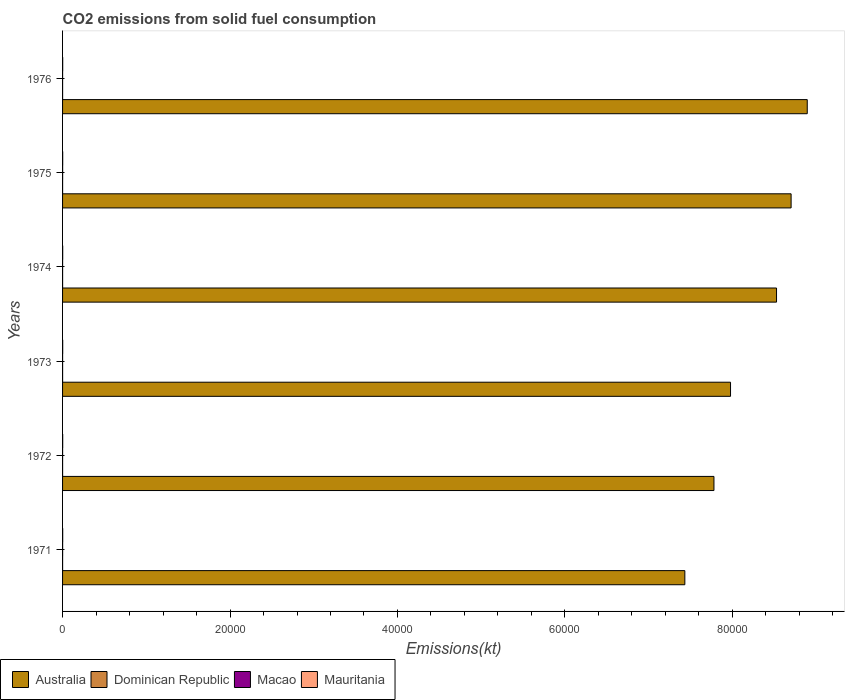How many different coloured bars are there?
Make the answer very short. 4. How many bars are there on the 4th tick from the top?
Offer a very short reply. 4. How many bars are there on the 6th tick from the bottom?
Make the answer very short. 4. What is the amount of CO2 emitted in Australia in 1973?
Provide a short and direct response. 7.98e+04. Across all years, what is the maximum amount of CO2 emitted in Macao?
Your response must be concise. 7.33. Across all years, what is the minimum amount of CO2 emitted in Australia?
Offer a terse response. 7.43e+04. What is the total amount of CO2 emitted in Dominican Republic in the graph?
Your answer should be very brief. 22. What is the difference between the amount of CO2 emitted in Macao in 1973 and the amount of CO2 emitted in Dominican Republic in 1974?
Your answer should be compact. 0. What is the average amount of CO2 emitted in Macao per year?
Your response must be concise. 4.89. In the year 1973, what is the difference between the amount of CO2 emitted in Dominican Republic and amount of CO2 emitted in Australia?
Offer a very short reply. -7.98e+04. In how many years, is the amount of CO2 emitted in Dominican Republic greater than 4000 kt?
Keep it short and to the point. 0. Is the amount of CO2 emitted in Australia in 1974 less than that in 1975?
Your answer should be compact. Yes. What is the difference between the highest and the lowest amount of CO2 emitted in Macao?
Make the answer very short. 3.67. In how many years, is the amount of CO2 emitted in Mauritania greater than the average amount of CO2 emitted in Mauritania taken over all years?
Ensure brevity in your answer.  0. Is the sum of the amount of CO2 emitted in Mauritania in 1972 and 1976 greater than the maximum amount of CO2 emitted in Dominican Republic across all years?
Keep it short and to the point. Yes. What does the 2nd bar from the top in 1971 represents?
Your answer should be compact. Macao. Are all the bars in the graph horizontal?
Your answer should be compact. Yes. How many years are there in the graph?
Offer a terse response. 6. What is the difference between two consecutive major ticks on the X-axis?
Provide a short and direct response. 2.00e+04. Are the values on the major ticks of X-axis written in scientific E-notation?
Offer a very short reply. No. Does the graph contain grids?
Your answer should be very brief. No. How many legend labels are there?
Provide a short and direct response. 4. How are the legend labels stacked?
Keep it short and to the point. Horizontal. What is the title of the graph?
Offer a very short reply. CO2 emissions from solid fuel consumption. What is the label or title of the X-axis?
Keep it short and to the point. Emissions(kt). What is the Emissions(kt) of Australia in 1971?
Your response must be concise. 7.43e+04. What is the Emissions(kt) in Dominican Republic in 1971?
Your answer should be compact. 3.67. What is the Emissions(kt) of Macao in 1971?
Provide a succinct answer. 7.33. What is the Emissions(kt) of Mauritania in 1971?
Ensure brevity in your answer.  14.67. What is the Emissions(kt) in Australia in 1972?
Make the answer very short. 7.78e+04. What is the Emissions(kt) in Dominican Republic in 1972?
Keep it short and to the point. 3.67. What is the Emissions(kt) of Macao in 1972?
Provide a short and direct response. 3.67. What is the Emissions(kt) of Mauritania in 1972?
Your answer should be compact. 14.67. What is the Emissions(kt) of Australia in 1973?
Make the answer very short. 7.98e+04. What is the Emissions(kt) in Dominican Republic in 1973?
Provide a short and direct response. 3.67. What is the Emissions(kt) in Macao in 1973?
Give a very brief answer. 3.67. What is the Emissions(kt) of Mauritania in 1973?
Your response must be concise. 14.67. What is the Emissions(kt) in Australia in 1974?
Your answer should be compact. 8.53e+04. What is the Emissions(kt) in Dominican Republic in 1974?
Provide a succinct answer. 3.67. What is the Emissions(kt) of Macao in 1974?
Ensure brevity in your answer.  3.67. What is the Emissions(kt) in Mauritania in 1974?
Provide a succinct answer. 14.67. What is the Emissions(kt) of Australia in 1975?
Your response must be concise. 8.70e+04. What is the Emissions(kt) of Dominican Republic in 1975?
Your answer should be very brief. 3.67. What is the Emissions(kt) of Macao in 1975?
Your answer should be compact. 7.33. What is the Emissions(kt) of Mauritania in 1975?
Give a very brief answer. 14.67. What is the Emissions(kt) of Australia in 1976?
Keep it short and to the point. 8.89e+04. What is the Emissions(kt) of Dominican Republic in 1976?
Keep it short and to the point. 3.67. What is the Emissions(kt) in Macao in 1976?
Your response must be concise. 3.67. What is the Emissions(kt) of Mauritania in 1976?
Provide a succinct answer. 14.67. Across all years, what is the maximum Emissions(kt) of Australia?
Your answer should be very brief. 8.89e+04. Across all years, what is the maximum Emissions(kt) of Dominican Republic?
Offer a very short reply. 3.67. Across all years, what is the maximum Emissions(kt) in Macao?
Your answer should be compact. 7.33. Across all years, what is the maximum Emissions(kt) of Mauritania?
Keep it short and to the point. 14.67. Across all years, what is the minimum Emissions(kt) in Australia?
Your answer should be very brief. 7.43e+04. Across all years, what is the minimum Emissions(kt) in Dominican Republic?
Your response must be concise. 3.67. Across all years, what is the minimum Emissions(kt) in Macao?
Offer a terse response. 3.67. Across all years, what is the minimum Emissions(kt) in Mauritania?
Your answer should be compact. 14.67. What is the total Emissions(kt) in Australia in the graph?
Give a very brief answer. 4.93e+05. What is the total Emissions(kt) in Dominican Republic in the graph?
Make the answer very short. 22. What is the total Emissions(kt) of Macao in the graph?
Your answer should be compact. 29.34. What is the total Emissions(kt) of Mauritania in the graph?
Give a very brief answer. 88.01. What is the difference between the Emissions(kt) in Australia in 1971 and that in 1972?
Offer a terse response. -3476.32. What is the difference between the Emissions(kt) in Dominican Republic in 1971 and that in 1972?
Make the answer very short. 0. What is the difference between the Emissions(kt) in Macao in 1971 and that in 1972?
Keep it short and to the point. 3.67. What is the difference between the Emissions(kt) of Mauritania in 1971 and that in 1972?
Provide a short and direct response. 0. What is the difference between the Emissions(kt) in Australia in 1971 and that in 1973?
Offer a terse response. -5456.5. What is the difference between the Emissions(kt) of Dominican Republic in 1971 and that in 1973?
Offer a very short reply. 0. What is the difference between the Emissions(kt) in Macao in 1971 and that in 1973?
Keep it short and to the point. 3.67. What is the difference between the Emissions(kt) in Mauritania in 1971 and that in 1973?
Keep it short and to the point. 0. What is the difference between the Emissions(kt) of Australia in 1971 and that in 1974?
Offer a very short reply. -1.09e+04. What is the difference between the Emissions(kt) of Dominican Republic in 1971 and that in 1974?
Provide a succinct answer. 0. What is the difference between the Emissions(kt) in Macao in 1971 and that in 1974?
Offer a very short reply. 3.67. What is the difference between the Emissions(kt) in Mauritania in 1971 and that in 1974?
Your answer should be compact. 0. What is the difference between the Emissions(kt) in Australia in 1971 and that in 1975?
Keep it short and to the point. -1.27e+04. What is the difference between the Emissions(kt) of Australia in 1971 and that in 1976?
Keep it short and to the point. -1.46e+04. What is the difference between the Emissions(kt) of Macao in 1971 and that in 1976?
Make the answer very short. 3.67. What is the difference between the Emissions(kt) in Mauritania in 1971 and that in 1976?
Your answer should be very brief. 0. What is the difference between the Emissions(kt) in Australia in 1972 and that in 1973?
Offer a terse response. -1980.18. What is the difference between the Emissions(kt) of Dominican Republic in 1972 and that in 1973?
Provide a short and direct response. 0. What is the difference between the Emissions(kt) of Macao in 1972 and that in 1973?
Your answer should be compact. 0. What is the difference between the Emissions(kt) of Mauritania in 1972 and that in 1973?
Ensure brevity in your answer.  0. What is the difference between the Emissions(kt) of Australia in 1972 and that in 1974?
Your response must be concise. -7473.35. What is the difference between the Emissions(kt) in Dominican Republic in 1972 and that in 1974?
Offer a very short reply. 0. What is the difference between the Emissions(kt) in Australia in 1972 and that in 1975?
Give a very brief answer. -9215.17. What is the difference between the Emissions(kt) of Macao in 1972 and that in 1975?
Provide a short and direct response. -3.67. What is the difference between the Emissions(kt) of Mauritania in 1972 and that in 1975?
Your response must be concise. 0. What is the difference between the Emissions(kt) of Australia in 1972 and that in 1976?
Your answer should be very brief. -1.11e+04. What is the difference between the Emissions(kt) of Dominican Republic in 1972 and that in 1976?
Your answer should be compact. 0. What is the difference between the Emissions(kt) of Macao in 1972 and that in 1976?
Your answer should be very brief. 0. What is the difference between the Emissions(kt) of Mauritania in 1972 and that in 1976?
Offer a terse response. 0. What is the difference between the Emissions(kt) in Australia in 1973 and that in 1974?
Your response must be concise. -5493.17. What is the difference between the Emissions(kt) in Dominican Republic in 1973 and that in 1974?
Give a very brief answer. 0. What is the difference between the Emissions(kt) of Macao in 1973 and that in 1974?
Provide a succinct answer. 0. What is the difference between the Emissions(kt) of Australia in 1973 and that in 1975?
Your response must be concise. -7234.99. What is the difference between the Emissions(kt) in Macao in 1973 and that in 1975?
Your response must be concise. -3.67. What is the difference between the Emissions(kt) of Australia in 1973 and that in 1976?
Your answer should be very brief. -9163.83. What is the difference between the Emissions(kt) of Dominican Republic in 1973 and that in 1976?
Make the answer very short. 0. What is the difference between the Emissions(kt) of Australia in 1974 and that in 1975?
Give a very brief answer. -1741.83. What is the difference between the Emissions(kt) of Dominican Republic in 1974 and that in 1975?
Offer a very short reply. 0. What is the difference between the Emissions(kt) of Macao in 1974 and that in 1975?
Ensure brevity in your answer.  -3.67. What is the difference between the Emissions(kt) in Mauritania in 1974 and that in 1975?
Provide a short and direct response. 0. What is the difference between the Emissions(kt) in Australia in 1974 and that in 1976?
Your answer should be very brief. -3670.67. What is the difference between the Emissions(kt) of Macao in 1974 and that in 1976?
Offer a terse response. 0. What is the difference between the Emissions(kt) of Mauritania in 1974 and that in 1976?
Keep it short and to the point. 0. What is the difference between the Emissions(kt) in Australia in 1975 and that in 1976?
Ensure brevity in your answer.  -1928.84. What is the difference between the Emissions(kt) of Dominican Republic in 1975 and that in 1976?
Keep it short and to the point. 0. What is the difference between the Emissions(kt) in Macao in 1975 and that in 1976?
Give a very brief answer. 3.67. What is the difference between the Emissions(kt) in Mauritania in 1975 and that in 1976?
Offer a very short reply. 0. What is the difference between the Emissions(kt) in Australia in 1971 and the Emissions(kt) in Dominican Republic in 1972?
Keep it short and to the point. 7.43e+04. What is the difference between the Emissions(kt) of Australia in 1971 and the Emissions(kt) of Macao in 1972?
Your response must be concise. 7.43e+04. What is the difference between the Emissions(kt) of Australia in 1971 and the Emissions(kt) of Mauritania in 1972?
Make the answer very short. 7.43e+04. What is the difference between the Emissions(kt) in Dominican Republic in 1971 and the Emissions(kt) in Macao in 1972?
Keep it short and to the point. 0. What is the difference between the Emissions(kt) in Dominican Republic in 1971 and the Emissions(kt) in Mauritania in 1972?
Your answer should be compact. -11. What is the difference between the Emissions(kt) of Macao in 1971 and the Emissions(kt) of Mauritania in 1972?
Ensure brevity in your answer.  -7.33. What is the difference between the Emissions(kt) in Australia in 1971 and the Emissions(kt) in Dominican Republic in 1973?
Your answer should be compact. 7.43e+04. What is the difference between the Emissions(kt) of Australia in 1971 and the Emissions(kt) of Macao in 1973?
Ensure brevity in your answer.  7.43e+04. What is the difference between the Emissions(kt) in Australia in 1971 and the Emissions(kt) in Mauritania in 1973?
Provide a short and direct response. 7.43e+04. What is the difference between the Emissions(kt) in Dominican Republic in 1971 and the Emissions(kt) in Mauritania in 1973?
Give a very brief answer. -11. What is the difference between the Emissions(kt) in Macao in 1971 and the Emissions(kt) in Mauritania in 1973?
Make the answer very short. -7.33. What is the difference between the Emissions(kt) in Australia in 1971 and the Emissions(kt) in Dominican Republic in 1974?
Provide a short and direct response. 7.43e+04. What is the difference between the Emissions(kt) of Australia in 1971 and the Emissions(kt) of Macao in 1974?
Your answer should be very brief. 7.43e+04. What is the difference between the Emissions(kt) of Australia in 1971 and the Emissions(kt) of Mauritania in 1974?
Provide a succinct answer. 7.43e+04. What is the difference between the Emissions(kt) of Dominican Republic in 1971 and the Emissions(kt) of Macao in 1974?
Provide a succinct answer. 0. What is the difference between the Emissions(kt) of Dominican Republic in 1971 and the Emissions(kt) of Mauritania in 1974?
Make the answer very short. -11. What is the difference between the Emissions(kt) in Macao in 1971 and the Emissions(kt) in Mauritania in 1974?
Provide a short and direct response. -7.33. What is the difference between the Emissions(kt) of Australia in 1971 and the Emissions(kt) of Dominican Republic in 1975?
Provide a succinct answer. 7.43e+04. What is the difference between the Emissions(kt) in Australia in 1971 and the Emissions(kt) in Macao in 1975?
Offer a very short reply. 7.43e+04. What is the difference between the Emissions(kt) of Australia in 1971 and the Emissions(kt) of Mauritania in 1975?
Make the answer very short. 7.43e+04. What is the difference between the Emissions(kt) in Dominican Republic in 1971 and the Emissions(kt) in Macao in 1975?
Your answer should be compact. -3.67. What is the difference between the Emissions(kt) in Dominican Republic in 1971 and the Emissions(kt) in Mauritania in 1975?
Your response must be concise. -11. What is the difference between the Emissions(kt) in Macao in 1971 and the Emissions(kt) in Mauritania in 1975?
Provide a short and direct response. -7.33. What is the difference between the Emissions(kt) of Australia in 1971 and the Emissions(kt) of Dominican Republic in 1976?
Ensure brevity in your answer.  7.43e+04. What is the difference between the Emissions(kt) in Australia in 1971 and the Emissions(kt) in Macao in 1976?
Give a very brief answer. 7.43e+04. What is the difference between the Emissions(kt) in Australia in 1971 and the Emissions(kt) in Mauritania in 1976?
Keep it short and to the point. 7.43e+04. What is the difference between the Emissions(kt) of Dominican Republic in 1971 and the Emissions(kt) of Mauritania in 1976?
Your response must be concise. -11. What is the difference between the Emissions(kt) of Macao in 1971 and the Emissions(kt) of Mauritania in 1976?
Your answer should be compact. -7.33. What is the difference between the Emissions(kt) of Australia in 1972 and the Emissions(kt) of Dominican Republic in 1973?
Make the answer very short. 7.78e+04. What is the difference between the Emissions(kt) in Australia in 1972 and the Emissions(kt) in Macao in 1973?
Offer a very short reply. 7.78e+04. What is the difference between the Emissions(kt) in Australia in 1972 and the Emissions(kt) in Mauritania in 1973?
Keep it short and to the point. 7.78e+04. What is the difference between the Emissions(kt) of Dominican Republic in 1972 and the Emissions(kt) of Macao in 1973?
Your answer should be very brief. 0. What is the difference between the Emissions(kt) in Dominican Republic in 1972 and the Emissions(kt) in Mauritania in 1973?
Keep it short and to the point. -11. What is the difference between the Emissions(kt) in Macao in 1972 and the Emissions(kt) in Mauritania in 1973?
Keep it short and to the point. -11. What is the difference between the Emissions(kt) of Australia in 1972 and the Emissions(kt) of Dominican Republic in 1974?
Give a very brief answer. 7.78e+04. What is the difference between the Emissions(kt) of Australia in 1972 and the Emissions(kt) of Macao in 1974?
Your response must be concise. 7.78e+04. What is the difference between the Emissions(kt) in Australia in 1972 and the Emissions(kt) in Mauritania in 1974?
Ensure brevity in your answer.  7.78e+04. What is the difference between the Emissions(kt) of Dominican Republic in 1972 and the Emissions(kt) of Mauritania in 1974?
Ensure brevity in your answer.  -11. What is the difference between the Emissions(kt) of Macao in 1972 and the Emissions(kt) of Mauritania in 1974?
Ensure brevity in your answer.  -11. What is the difference between the Emissions(kt) in Australia in 1972 and the Emissions(kt) in Dominican Republic in 1975?
Your answer should be very brief. 7.78e+04. What is the difference between the Emissions(kt) in Australia in 1972 and the Emissions(kt) in Macao in 1975?
Your answer should be compact. 7.78e+04. What is the difference between the Emissions(kt) in Australia in 1972 and the Emissions(kt) in Mauritania in 1975?
Your answer should be very brief. 7.78e+04. What is the difference between the Emissions(kt) in Dominican Republic in 1972 and the Emissions(kt) in Macao in 1975?
Your answer should be very brief. -3.67. What is the difference between the Emissions(kt) in Dominican Republic in 1972 and the Emissions(kt) in Mauritania in 1975?
Provide a short and direct response. -11. What is the difference between the Emissions(kt) of Macao in 1972 and the Emissions(kt) of Mauritania in 1975?
Your answer should be compact. -11. What is the difference between the Emissions(kt) in Australia in 1972 and the Emissions(kt) in Dominican Republic in 1976?
Your response must be concise. 7.78e+04. What is the difference between the Emissions(kt) of Australia in 1972 and the Emissions(kt) of Macao in 1976?
Offer a terse response. 7.78e+04. What is the difference between the Emissions(kt) of Australia in 1972 and the Emissions(kt) of Mauritania in 1976?
Offer a very short reply. 7.78e+04. What is the difference between the Emissions(kt) of Dominican Republic in 1972 and the Emissions(kt) of Macao in 1976?
Offer a very short reply. 0. What is the difference between the Emissions(kt) of Dominican Republic in 1972 and the Emissions(kt) of Mauritania in 1976?
Your answer should be very brief. -11. What is the difference between the Emissions(kt) in Macao in 1972 and the Emissions(kt) in Mauritania in 1976?
Provide a short and direct response. -11. What is the difference between the Emissions(kt) of Australia in 1973 and the Emissions(kt) of Dominican Republic in 1974?
Your response must be concise. 7.98e+04. What is the difference between the Emissions(kt) of Australia in 1973 and the Emissions(kt) of Macao in 1974?
Your answer should be very brief. 7.98e+04. What is the difference between the Emissions(kt) of Australia in 1973 and the Emissions(kt) of Mauritania in 1974?
Your response must be concise. 7.98e+04. What is the difference between the Emissions(kt) in Dominican Republic in 1973 and the Emissions(kt) in Macao in 1974?
Ensure brevity in your answer.  0. What is the difference between the Emissions(kt) in Dominican Republic in 1973 and the Emissions(kt) in Mauritania in 1974?
Your answer should be compact. -11. What is the difference between the Emissions(kt) of Macao in 1973 and the Emissions(kt) of Mauritania in 1974?
Your answer should be compact. -11. What is the difference between the Emissions(kt) of Australia in 1973 and the Emissions(kt) of Dominican Republic in 1975?
Your answer should be compact. 7.98e+04. What is the difference between the Emissions(kt) of Australia in 1973 and the Emissions(kt) of Macao in 1975?
Your response must be concise. 7.98e+04. What is the difference between the Emissions(kt) in Australia in 1973 and the Emissions(kt) in Mauritania in 1975?
Your response must be concise. 7.98e+04. What is the difference between the Emissions(kt) in Dominican Republic in 1973 and the Emissions(kt) in Macao in 1975?
Offer a very short reply. -3.67. What is the difference between the Emissions(kt) in Dominican Republic in 1973 and the Emissions(kt) in Mauritania in 1975?
Ensure brevity in your answer.  -11. What is the difference between the Emissions(kt) of Macao in 1973 and the Emissions(kt) of Mauritania in 1975?
Provide a succinct answer. -11. What is the difference between the Emissions(kt) in Australia in 1973 and the Emissions(kt) in Dominican Republic in 1976?
Provide a succinct answer. 7.98e+04. What is the difference between the Emissions(kt) in Australia in 1973 and the Emissions(kt) in Macao in 1976?
Your answer should be compact. 7.98e+04. What is the difference between the Emissions(kt) in Australia in 1973 and the Emissions(kt) in Mauritania in 1976?
Make the answer very short. 7.98e+04. What is the difference between the Emissions(kt) of Dominican Republic in 1973 and the Emissions(kt) of Mauritania in 1976?
Offer a very short reply. -11. What is the difference between the Emissions(kt) in Macao in 1973 and the Emissions(kt) in Mauritania in 1976?
Offer a terse response. -11. What is the difference between the Emissions(kt) in Australia in 1974 and the Emissions(kt) in Dominican Republic in 1975?
Provide a succinct answer. 8.53e+04. What is the difference between the Emissions(kt) of Australia in 1974 and the Emissions(kt) of Macao in 1975?
Give a very brief answer. 8.53e+04. What is the difference between the Emissions(kt) of Australia in 1974 and the Emissions(kt) of Mauritania in 1975?
Offer a very short reply. 8.53e+04. What is the difference between the Emissions(kt) in Dominican Republic in 1974 and the Emissions(kt) in Macao in 1975?
Your response must be concise. -3.67. What is the difference between the Emissions(kt) of Dominican Republic in 1974 and the Emissions(kt) of Mauritania in 1975?
Give a very brief answer. -11. What is the difference between the Emissions(kt) in Macao in 1974 and the Emissions(kt) in Mauritania in 1975?
Make the answer very short. -11. What is the difference between the Emissions(kt) of Australia in 1974 and the Emissions(kt) of Dominican Republic in 1976?
Your answer should be very brief. 8.53e+04. What is the difference between the Emissions(kt) of Australia in 1974 and the Emissions(kt) of Macao in 1976?
Your answer should be very brief. 8.53e+04. What is the difference between the Emissions(kt) of Australia in 1974 and the Emissions(kt) of Mauritania in 1976?
Your response must be concise. 8.53e+04. What is the difference between the Emissions(kt) of Dominican Republic in 1974 and the Emissions(kt) of Macao in 1976?
Offer a very short reply. 0. What is the difference between the Emissions(kt) of Dominican Republic in 1974 and the Emissions(kt) of Mauritania in 1976?
Provide a succinct answer. -11. What is the difference between the Emissions(kt) of Macao in 1974 and the Emissions(kt) of Mauritania in 1976?
Provide a short and direct response. -11. What is the difference between the Emissions(kt) of Australia in 1975 and the Emissions(kt) of Dominican Republic in 1976?
Ensure brevity in your answer.  8.70e+04. What is the difference between the Emissions(kt) of Australia in 1975 and the Emissions(kt) of Macao in 1976?
Offer a terse response. 8.70e+04. What is the difference between the Emissions(kt) of Australia in 1975 and the Emissions(kt) of Mauritania in 1976?
Provide a succinct answer. 8.70e+04. What is the difference between the Emissions(kt) of Dominican Republic in 1975 and the Emissions(kt) of Mauritania in 1976?
Offer a very short reply. -11. What is the difference between the Emissions(kt) in Macao in 1975 and the Emissions(kt) in Mauritania in 1976?
Offer a terse response. -7.33. What is the average Emissions(kt) in Australia per year?
Keep it short and to the point. 8.22e+04. What is the average Emissions(kt) of Dominican Republic per year?
Provide a succinct answer. 3.67. What is the average Emissions(kt) of Macao per year?
Keep it short and to the point. 4.89. What is the average Emissions(kt) in Mauritania per year?
Keep it short and to the point. 14.67. In the year 1971, what is the difference between the Emissions(kt) of Australia and Emissions(kt) of Dominican Republic?
Ensure brevity in your answer.  7.43e+04. In the year 1971, what is the difference between the Emissions(kt) in Australia and Emissions(kt) in Macao?
Your answer should be very brief. 7.43e+04. In the year 1971, what is the difference between the Emissions(kt) of Australia and Emissions(kt) of Mauritania?
Make the answer very short. 7.43e+04. In the year 1971, what is the difference between the Emissions(kt) of Dominican Republic and Emissions(kt) of Macao?
Give a very brief answer. -3.67. In the year 1971, what is the difference between the Emissions(kt) of Dominican Republic and Emissions(kt) of Mauritania?
Your answer should be compact. -11. In the year 1971, what is the difference between the Emissions(kt) in Macao and Emissions(kt) in Mauritania?
Your answer should be compact. -7.33. In the year 1972, what is the difference between the Emissions(kt) of Australia and Emissions(kt) of Dominican Republic?
Keep it short and to the point. 7.78e+04. In the year 1972, what is the difference between the Emissions(kt) of Australia and Emissions(kt) of Macao?
Provide a succinct answer. 7.78e+04. In the year 1972, what is the difference between the Emissions(kt) of Australia and Emissions(kt) of Mauritania?
Provide a succinct answer. 7.78e+04. In the year 1972, what is the difference between the Emissions(kt) in Dominican Republic and Emissions(kt) in Mauritania?
Ensure brevity in your answer.  -11. In the year 1972, what is the difference between the Emissions(kt) of Macao and Emissions(kt) of Mauritania?
Give a very brief answer. -11. In the year 1973, what is the difference between the Emissions(kt) of Australia and Emissions(kt) of Dominican Republic?
Your answer should be very brief. 7.98e+04. In the year 1973, what is the difference between the Emissions(kt) of Australia and Emissions(kt) of Macao?
Offer a very short reply. 7.98e+04. In the year 1973, what is the difference between the Emissions(kt) of Australia and Emissions(kt) of Mauritania?
Your answer should be very brief. 7.98e+04. In the year 1973, what is the difference between the Emissions(kt) in Dominican Republic and Emissions(kt) in Macao?
Give a very brief answer. 0. In the year 1973, what is the difference between the Emissions(kt) of Dominican Republic and Emissions(kt) of Mauritania?
Your response must be concise. -11. In the year 1973, what is the difference between the Emissions(kt) of Macao and Emissions(kt) of Mauritania?
Give a very brief answer. -11. In the year 1974, what is the difference between the Emissions(kt) in Australia and Emissions(kt) in Dominican Republic?
Offer a terse response. 8.53e+04. In the year 1974, what is the difference between the Emissions(kt) in Australia and Emissions(kt) in Macao?
Offer a very short reply. 8.53e+04. In the year 1974, what is the difference between the Emissions(kt) of Australia and Emissions(kt) of Mauritania?
Offer a terse response. 8.53e+04. In the year 1974, what is the difference between the Emissions(kt) in Dominican Republic and Emissions(kt) in Macao?
Your answer should be very brief. 0. In the year 1974, what is the difference between the Emissions(kt) of Dominican Republic and Emissions(kt) of Mauritania?
Offer a very short reply. -11. In the year 1974, what is the difference between the Emissions(kt) in Macao and Emissions(kt) in Mauritania?
Your answer should be compact. -11. In the year 1975, what is the difference between the Emissions(kt) of Australia and Emissions(kt) of Dominican Republic?
Keep it short and to the point. 8.70e+04. In the year 1975, what is the difference between the Emissions(kt) in Australia and Emissions(kt) in Macao?
Provide a short and direct response. 8.70e+04. In the year 1975, what is the difference between the Emissions(kt) of Australia and Emissions(kt) of Mauritania?
Your answer should be very brief. 8.70e+04. In the year 1975, what is the difference between the Emissions(kt) of Dominican Republic and Emissions(kt) of Macao?
Your response must be concise. -3.67. In the year 1975, what is the difference between the Emissions(kt) in Dominican Republic and Emissions(kt) in Mauritania?
Offer a terse response. -11. In the year 1975, what is the difference between the Emissions(kt) of Macao and Emissions(kt) of Mauritania?
Give a very brief answer. -7.33. In the year 1976, what is the difference between the Emissions(kt) in Australia and Emissions(kt) in Dominican Republic?
Ensure brevity in your answer.  8.89e+04. In the year 1976, what is the difference between the Emissions(kt) in Australia and Emissions(kt) in Macao?
Offer a very short reply. 8.89e+04. In the year 1976, what is the difference between the Emissions(kt) of Australia and Emissions(kt) of Mauritania?
Offer a very short reply. 8.89e+04. In the year 1976, what is the difference between the Emissions(kt) of Dominican Republic and Emissions(kt) of Macao?
Your answer should be very brief. 0. In the year 1976, what is the difference between the Emissions(kt) of Dominican Republic and Emissions(kt) of Mauritania?
Give a very brief answer. -11. In the year 1976, what is the difference between the Emissions(kt) of Macao and Emissions(kt) of Mauritania?
Keep it short and to the point. -11. What is the ratio of the Emissions(kt) of Australia in 1971 to that in 1972?
Offer a very short reply. 0.96. What is the ratio of the Emissions(kt) of Dominican Republic in 1971 to that in 1972?
Give a very brief answer. 1. What is the ratio of the Emissions(kt) in Macao in 1971 to that in 1972?
Your response must be concise. 2. What is the ratio of the Emissions(kt) in Mauritania in 1971 to that in 1972?
Your answer should be very brief. 1. What is the ratio of the Emissions(kt) of Australia in 1971 to that in 1973?
Your answer should be very brief. 0.93. What is the ratio of the Emissions(kt) of Mauritania in 1971 to that in 1973?
Provide a succinct answer. 1. What is the ratio of the Emissions(kt) in Australia in 1971 to that in 1974?
Your response must be concise. 0.87. What is the ratio of the Emissions(kt) in Dominican Republic in 1971 to that in 1974?
Keep it short and to the point. 1. What is the ratio of the Emissions(kt) of Macao in 1971 to that in 1974?
Offer a very short reply. 2. What is the ratio of the Emissions(kt) of Mauritania in 1971 to that in 1974?
Give a very brief answer. 1. What is the ratio of the Emissions(kt) of Australia in 1971 to that in 1975?
Ensure brevity in your answer.  0.85. What is the ratio of the Emissions(kt) in Dominican Republic in 1971 to that in 1975?
Your answer should be compact. 1. What is the ratio of the Emissions(kt) in Macao in 1971 to that in 1975?
Ensure brevity in your answer.  1. What is the ratio of the Emissions(kt) of Mauritania in 1971 to that in 1975?
Provide a short and direct response. 1. What is the ratio of the Emissions(kt) in Australia in 1971 to that in 1976?
Your answer should be compact. 0.84. What is the ratio of the Emissions(kt) of Dominican Republic in 1971 to that in 1976?
Ensure brevity in your answer.  1. What is the ratio of the Emissions(kt) in Australia in 1972 to that in 1973?
Give a very brief answer. 0.98. What is the ratio of the Emissions(kt) of Dominican Republic in 1972 to that in 1973?
Your answer should be very brief. 1. What is the ratio of the Emissions(kt) of Macao in 1972 to that in 1973?
Ensure brevity in your answer.  1. What is the ratio of the Emissions(kt) in Mauritania in 1972 to that in 1973?
Provide a succinct answer. 1. What is the ratio of the Emissions(kt) in Australia in 1972 to that in 1974?
Offer a very short reply. 0.91. What is the ratio of the Emissions(kt) of Dominican Republic in 1972 to that in 1974?
Keep it short and to the point. 1. What is the ratio of the Emissions(kt) in Macao in 1972 to that in 1974?
Offer a very short reply. 1. What is the ratio of the Emissions(kt) in Mauritania in 1972 to that in 1974?
Offer a terse response. 1. What is the ratio of the Emissions(kt) of Australia in 1972 to that in 1975?
Offer a terse response. 0.89. What is the ratio of the Emissions(kt) in Australia in 1972 to that in 1976?
Your answer should be very brief. 0.87. What is the ratio of the Emissions(kt) in Dominican Republic in 1972 to that in 1976?
Offer a very short reply. 1. What is the ratio of the Emissions(kt) in Mauritania in 1972 to that in 1976?
Offer a terse response. 1. What is the ratio of the Emissions(kt) in Australia in 1973 to that in 1974?
Your answer should be compact. 0.94. What is the ratio of the Emissions(kt) in Macao in 1973 to that in 1974?
Ensure brevity in your answer.  1. What is the ratio of the Emissions(kt) in Mauritania in 1973 to that in 1974?
Offer a terse response. 1. What is the ratio of the Emissions(kt) in Australia in 1973 to that in 1975?
Make the answer very short. 0.92. What is the ratio of the Emissions(kt) of Macao in 1973 to that in 1975?
Ensure brevity in your answer.  0.5. What is the ratio of the Emissions(kt) of Australia in 1973 to that in 1976?
Make the answer very short. 0.9. What is the ratio of the Emissions(kt) in Macao in 1973 to that in 1976?
Provide a short and direct response. 1. What is the ratio of the Emissions(kt) in Australia in 1974 to that in 1975?
Offer a very short reply. 0.98. What is the ratio of the Emissions(kt) in Australia in 1974 to that in 1976?
Provide a short and direct response. 0.96. What is the ratio of the Emissions(kt) of Dominican Republic in 1974 to that in 1976?
Provide a succinct answer. 1. What is the ratio of the Emissions(kt) of Macao in 1974 to that in 1976?
Offer a very short reply. 1. What is the ratio of the Emissions(kt) of Australia in 1975 to that in 1976?
Offer a terse response. 0.98. What is the ratio of the Emissions(kt) in Macao in 1975 to that in 1976?
Keep it short and to the point. 2. What is the difference between the highest and the second highest Emissions(kt) in Australia?
Your response must be concise. 1928.84. What is the difference between the highest and the second highest Emissions(kt) of Dominican Republic?
Your answer should be compact. 0. What is the difference between the highest and the second highest Emissions(kt) in Macao?
Offer a very short reply. 0. What is the difference between the highest and the second highest Emissions(kt) of Mauritania?
Provide a succinct answer. 0. What is the difference between the highest and the lowest Emissions(kt) of Australia?
Make the answer very short. 1.46e+04. What is the difference between the highest and the lowest Emissions(kt) of Dominican Republic?
Your answer should be very brief. 0. What is the difference between the highest and the lowest Emissions(kt) of Macao?
Provide a short and direct response. 3.67. What is the difference between the highest and the lowest Emissions(kt) in Mauritania?
Give a very brief answer. 0. 